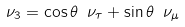<formula> <loc_0><loc_0><loc_500><loc_500>\nu _ { 3 } = \cos \theta \ \nu _ { \tau } + \sin \theta \ \nu _ { \mu }</formula> 